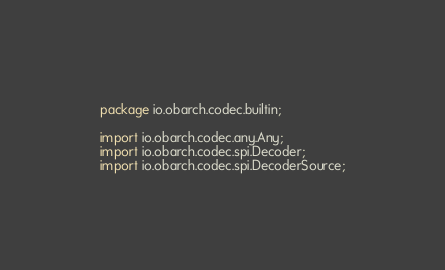Convert code to text. <code><loc_0><loc_0><loc_500><loc_500><_Java_>package io.obarch.codec.builtin;

import io.obarch.codec.any.Any;
import io.obarch.codec.spi.Decoder;
import io.obarch.codec.spi.DecoderSource;</code> 